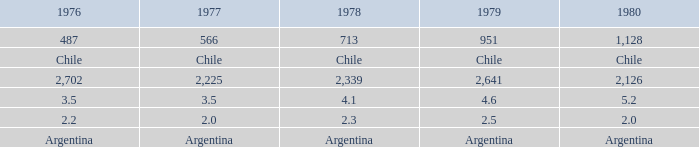What is 1976 when 1977 is 3.5? 3.5. 